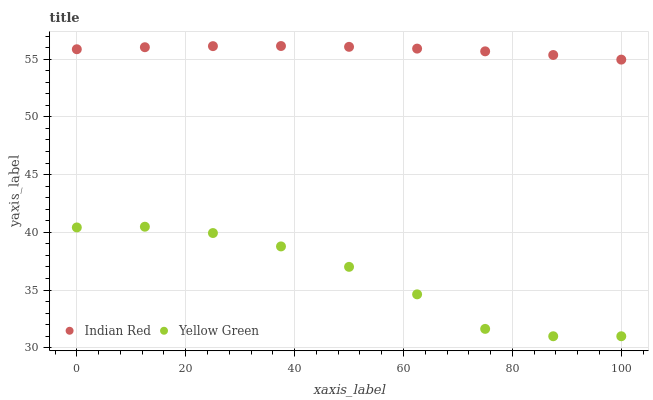Does Yellow Green have the minimum area under the curve?
Answer yes or no. Yes. Does Indian Red have the maximum area under the curve?
Answer yes or no. Yes. Does Indian Red have the minimum area under the curve?
Answer yes or no. No. Is Indian Red the smoothest?
Answer yes or no. Yes. Is Yellow Green the roughest?
Answer yes or no. Yes. Is Indian Red the roughest?
Answer yes or no. No. Does Yellow Green have the lowest value?
Answer yes or no. Yes. Does Indian Red have the lowest value?
Answer yes or no. No. Does Indian Red have the highest value?
Answer yes or no. Yes. Is Yellow Green less than Indian Red?
Answer yes or no. Yes. Is Indian Red greater than Yellow Green?
Answer yes or no. Yes. Does Yellow Green intersect Indian Red?
Answer yes or no. No. 